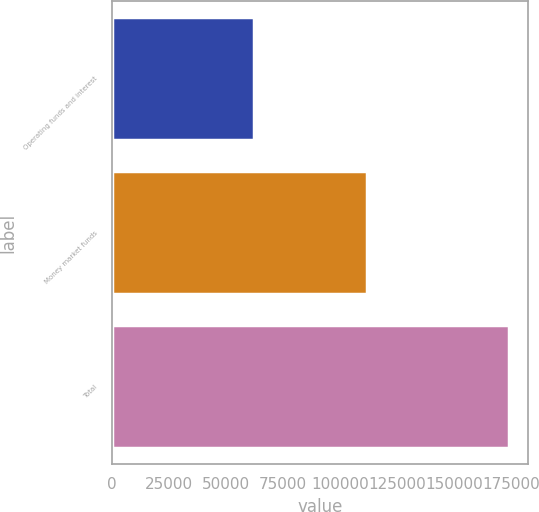Convert chart. <chart><loc_0><loc_0><loc_500><loc_500><bar_chart><fcel>Operating funds and interest<fcel>Money market funds<fcel>Total<nl><fcel>62221<fcel>111588<fcel>173809<nl></chart> 